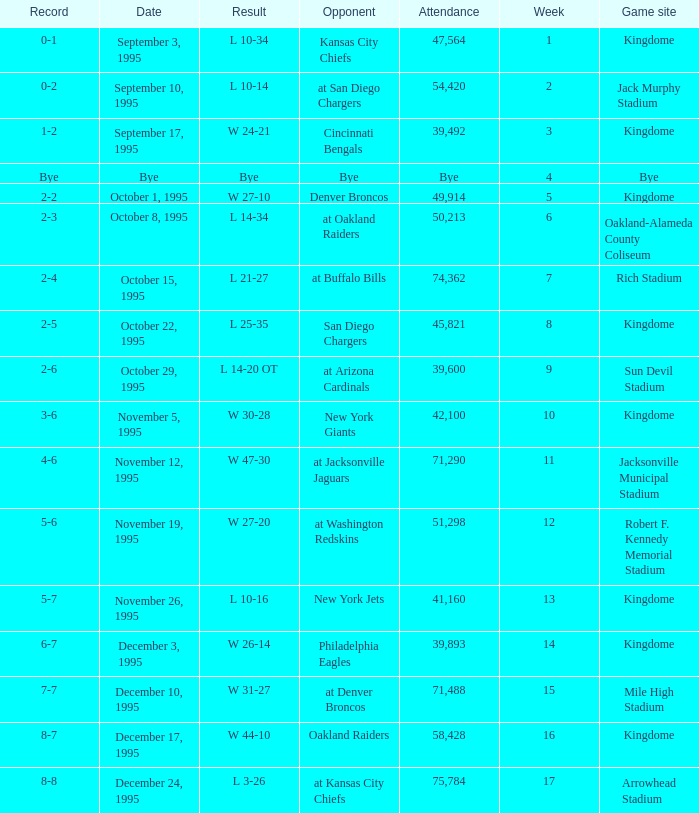When the seattle seahawks had an 8-7 record, who were they up against? Oakland Raiders. 